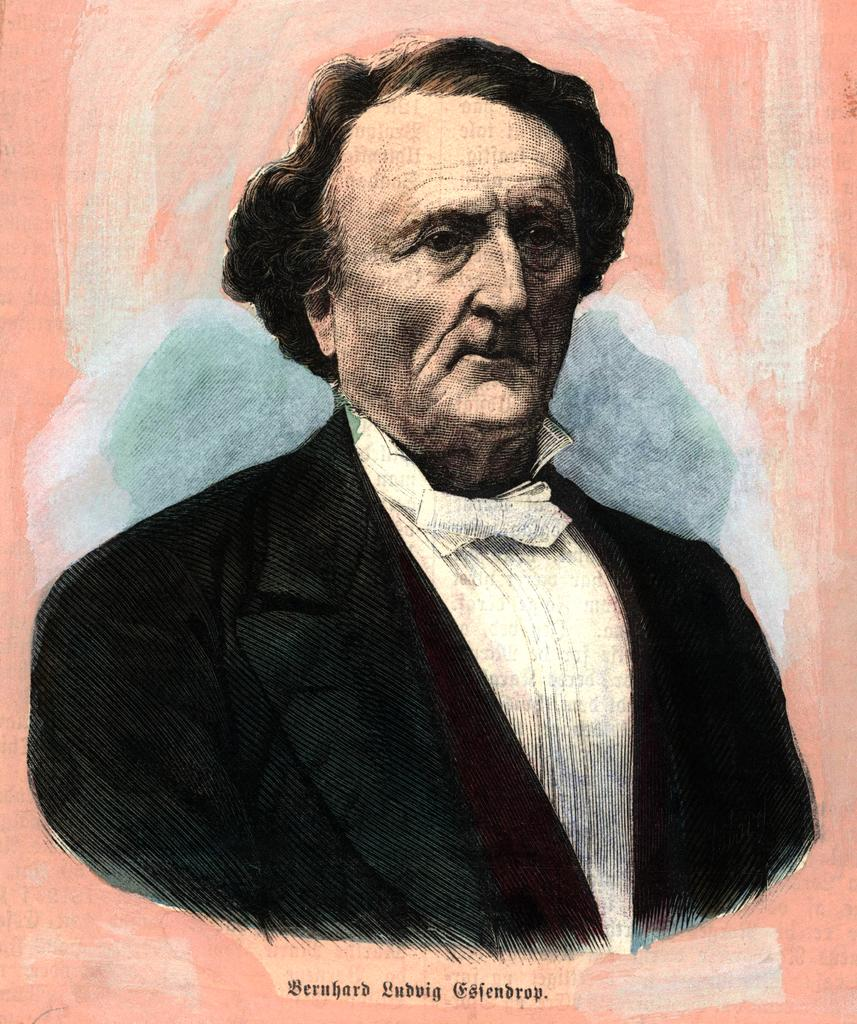What is the main subject of the image? The main subject of the image is a person. What type of artwork is the image? The image is a painting. Is there any text or label on the painting? Yes, there is a name on the painting. What type of machine is depicted in the painting? There is no machine depicted in the painting; it is a portrait of a person. How many beans are visible in the painting? There are no beans present in the painting. 